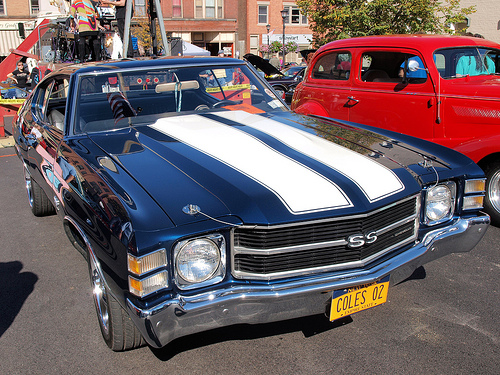<image>
Is there a red car to the left of the blue car? No. The red car is not to the left of the blue car. From this viewpoint, they have a different horizontal relationship. 